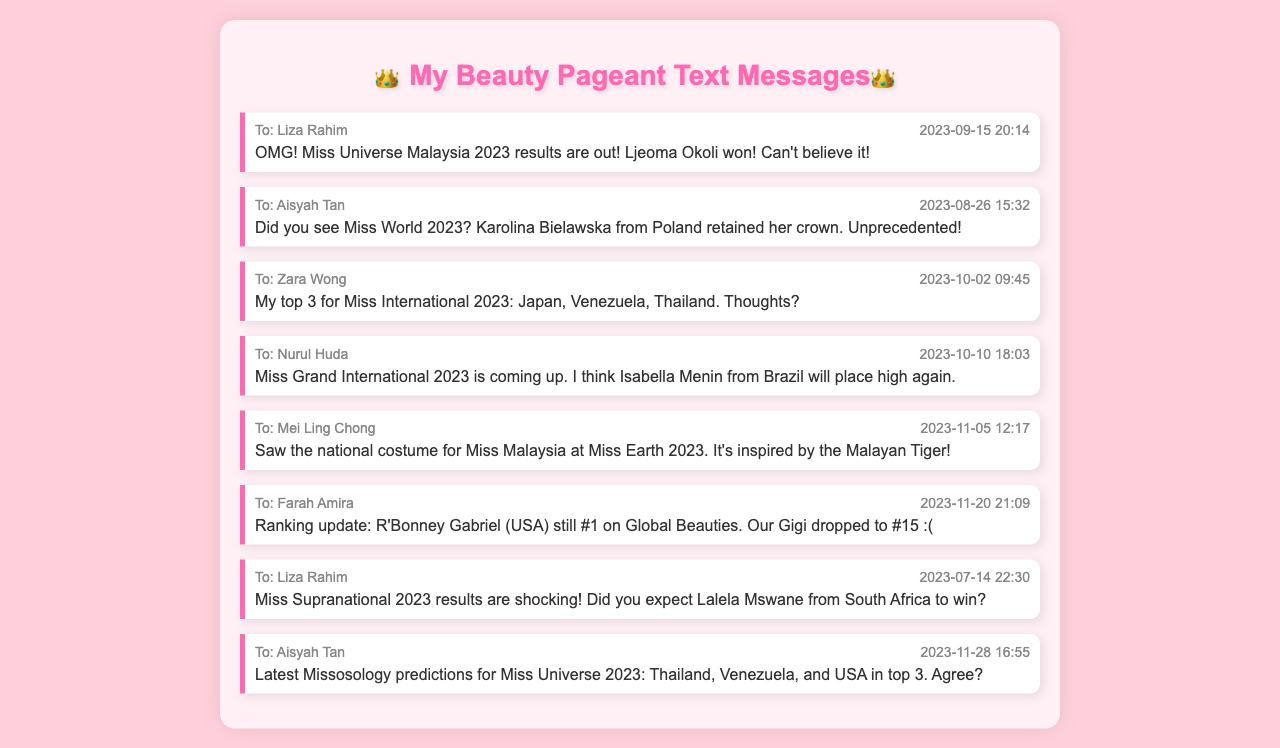What date did Ljeoma Okoli win Miss Universe Malaysia 2023? The text message states that the results were out on 2023-09-15 when Ljeoma Okoli won.
Answer: 2023-09-15 Who retained the Miss World 2023 crown? The message mentions that Karolina Bielawska from Poland retained her crown.
Answer: Karolina Bielawska What are the top 3 contestants mentioned for Miss International 2023? The message lists Japan, Venezuela, and Thailand as the top 3 contestants.
Answer: Japan, Venezuela, Thailand Which contestant is currently ranked #1 on Global Beauties? The message states that R'Bonney Gabriel from the USA is #1 on Global Beauties.
Answer: R'Bonney Gabriel What inspired the national costume for Miss Malaysia at Miss Earth 2023? The text message indicates that the national costume is inspired by the Malayan Tiger.
Answer: Malayan Tiger How did Gigi rank in the latest update? The message mentions that Gigi dropped to #15 in the ranking update.
Answer: #15 When is the Miss Grand International 2023 competition taking place? The message says that Miss Grand International 2023 is coming up but doesn't specify the date.
Answer: Coming up Who did the latest Missosology predictions for Miss Universe 2023 include in the top 3? The message specifies Thailand, Venezuela, and USA in the top 3.
Answer: Thailand, Venezuela, USA 